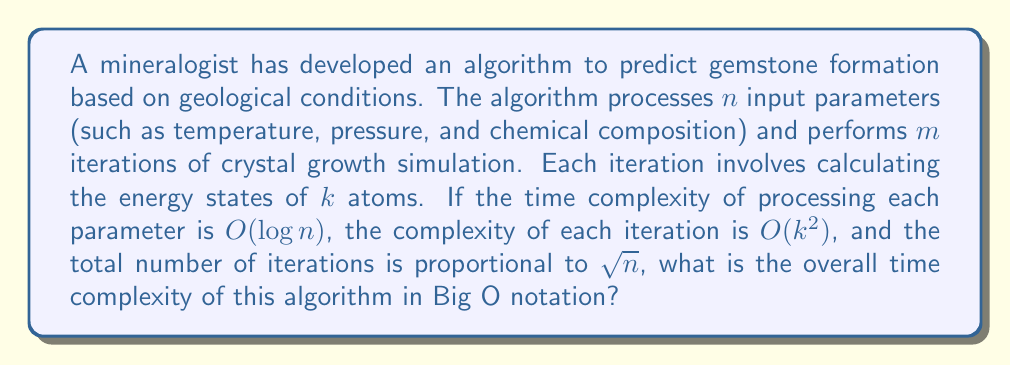Can you answer this question? Let's break down the problem and analyze the time complexity step by step:

1. Processing input parameters:
   - Time complexity for each parameter: $O(\log n)$
   - Total number of parameters: $n$
   - Total time for processing parameters: $O(n \log n)$

2. Crystal growth simulation:
   - Number of iterations: $m = O(\sqrt{n})$
   - Complexity of each iteration: $O(k^2)$
   - Total time for simulations: $O(m \cdot k^2) = O(\sqrt{n} \cdot k^2)$

3. Combining the complexities:
   The total time complexity is the sum of the two main parts:
   $$O(n \log n + \sqrt{n} \cdot k^2)$$

4. Simplifying:
   - As $n$ grows, $n \log n$ will dominate $\sqrt{n}$
   - $k$ is a constant factor in this context
   
   Therefore, the overall time complexity simplifies to:
   $$O(n \log n)$$

This representation captures the dominant term that grows fastest as the input size increases.
Answer: $O(n \log n)$ 